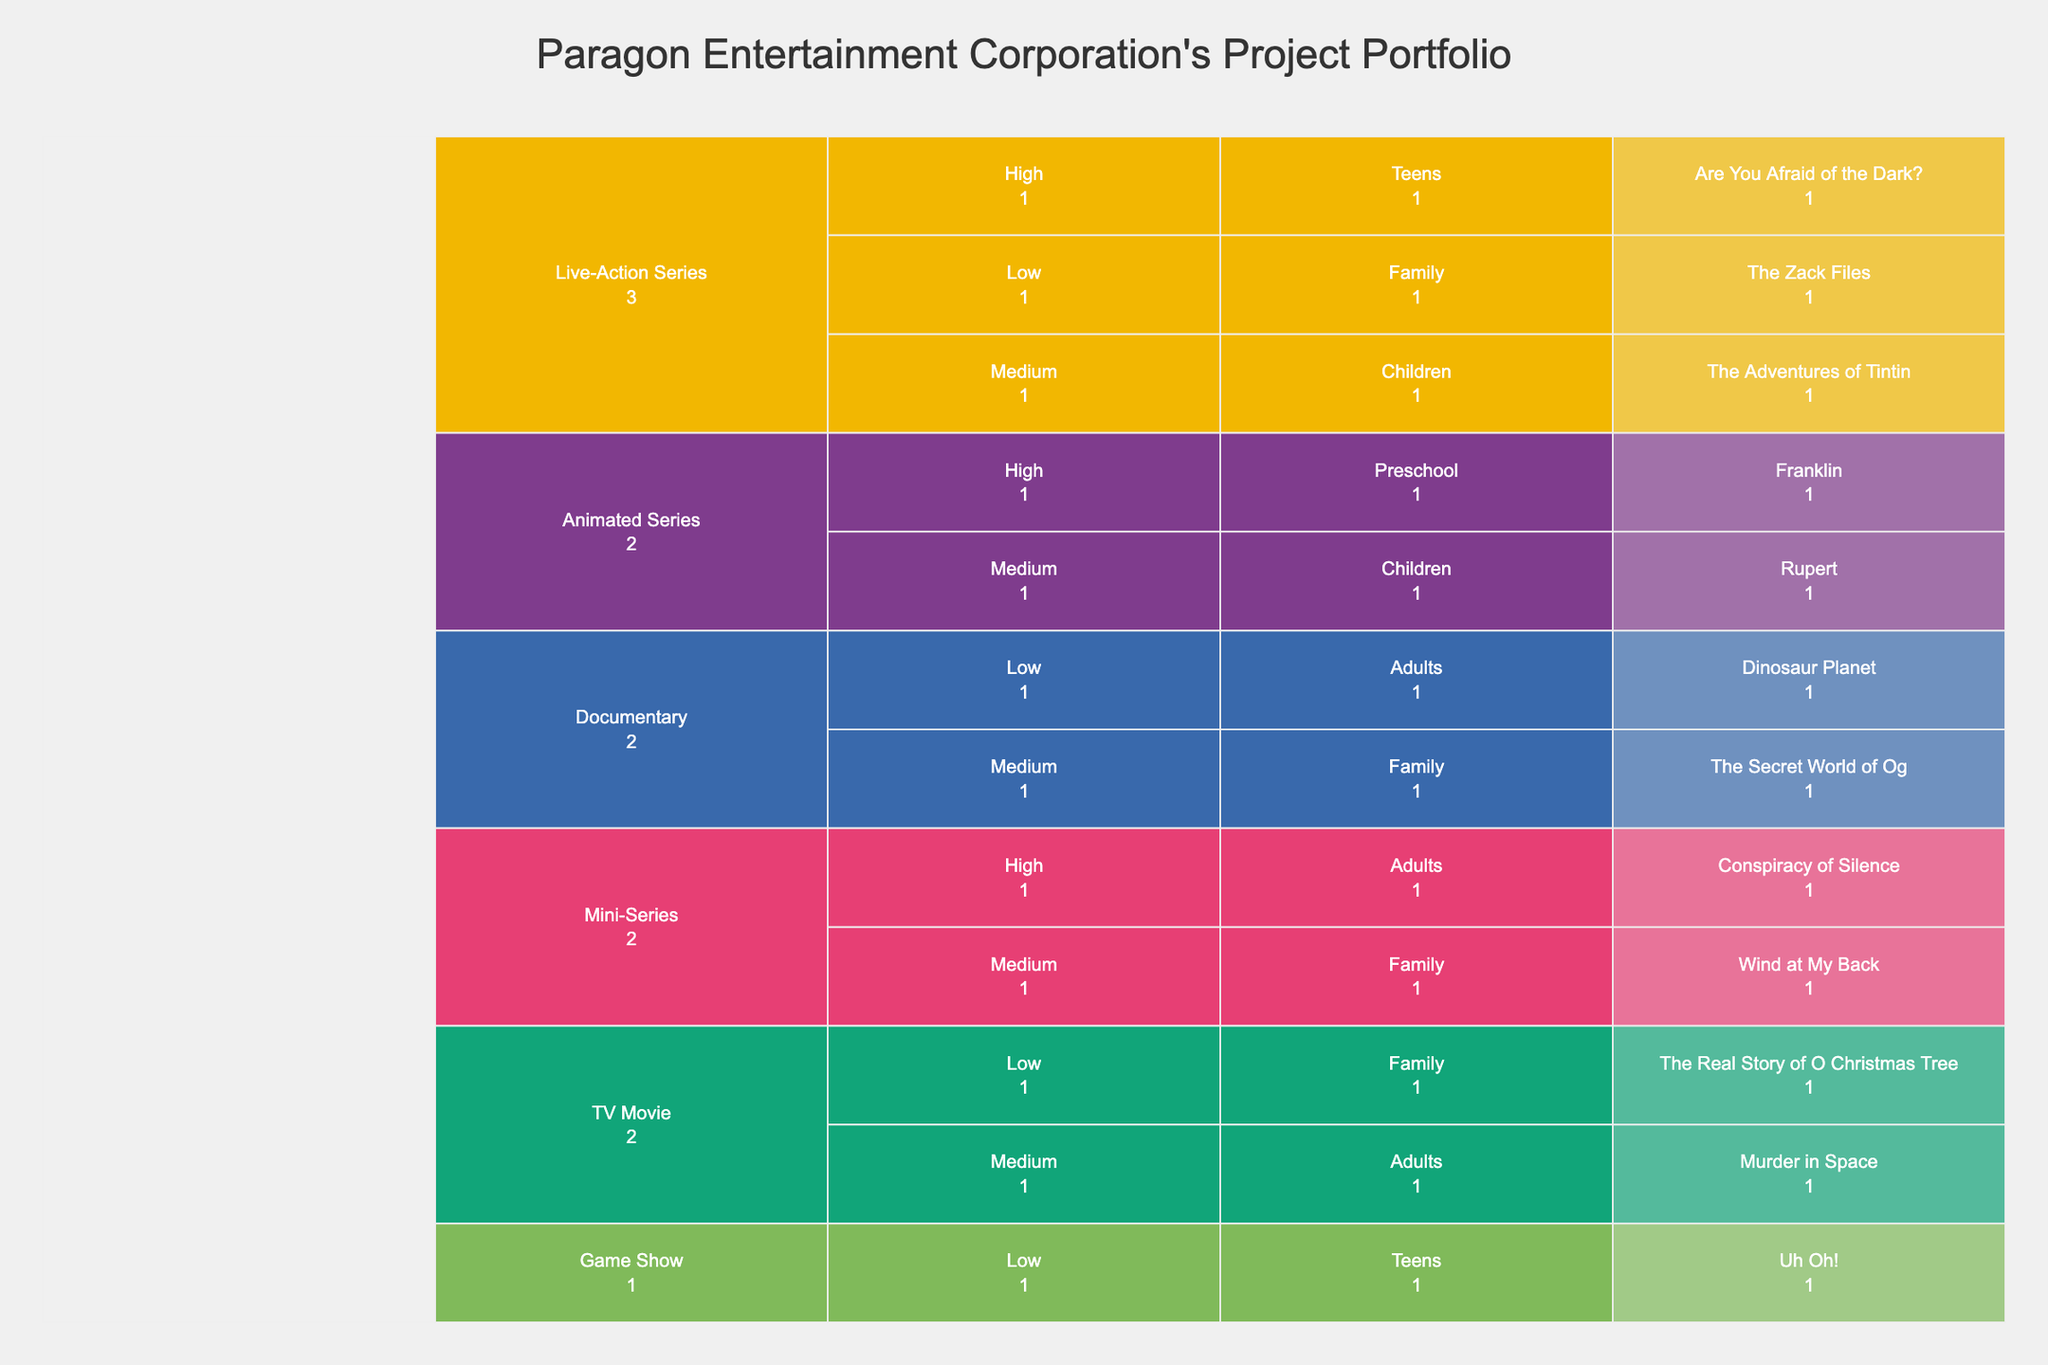What is the title of the icicle chart? The title is presented at the top of the icicle chart. It states what the chart is about.
Answer: Paragon Entertainment Corporation's Project Portfolio How many different project types are shown in the icicle chart? The icicle chart displays each project type as a distinct segment. Count the number of segments at the highest level.
Answer: 5 Which project has the highest budget targeting preschool audiences? Navigate through the hierarchy of project types and budget ranges, and look for segments labeled with "Preschool" to identify the project.
Answer: Franklin How many projects have a low budget? Check all segments under each project type grouped by "Low" budget range. Count them.
Answer: 4 What is the target audience for the TV Movie titled "Murder in Space"? Locate the segment labeled "TV Movie", then navigate to the segment labeled "Murder in Space" and identify the associated target audience.
Answer: Adults Which project types do not have any high-budget projects? Identify the segments representing different project types and see which ones lack any child segments under the "High" budget range.
Answer: Game Show, Documentary How many live-action series are targeted at children? Within the "Live-Action Series" segment, count the projects under the "Children" target audience category.
Answer: 1 Among the target audiences, which one has the most projects across all project types and budget ranges? Tally the total number of projects under each target audience category and compare.
Answer: Family Are there more medium-budget or low-budget projects? Count the total number of projects listed under "Medium" and "Low" budget ranges, then compare the two totals.
Answer: Medium Which type has the most varied target audiences? Identify which project type has segments with the greatest variety of target audience labels underneath it.
Answer: Mini-Series 